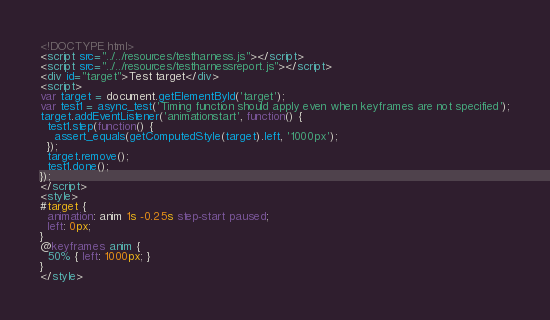<code> <loc_0><loc_0><loc_500><loc_500><_HTML_><!DOCTYPE html>
<script src="../../resources/testharness.js"></script>
<script src="../../resources/testharnessreport.js"></script>
<div id="target">Test target</div>
<script>
var target = document.getElementById('target');
var test1 = async_test('Timing function should apply even when keyframes are not specified');
target.addEventListener('animationstart', function() {
  test1.step(function() {
    assert_equals(getComputedStyle(target).left, '1000px');
  });
  target.remove();
  test1.done();
});
</script>
<style>
#target {
  animation: anim 1s -0.25s step-start paused;
  left: 0px;
}
@keyframes anim {
  50% { left: 1000px; }
}
</style>
</code> 